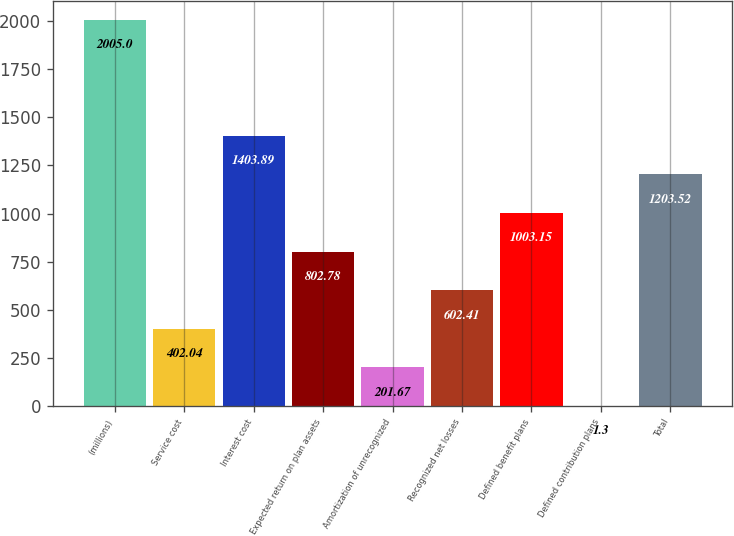Convert chart. <chart><loc_0><loc_0><loc_500><loc_500><bar_chart><fcel>(millions)<fcel>Service cost<fcel>Interest cost<fcel>Expected return on plan assets<fcel>Amortization of unrecognized<fcel>Recognized net losses<fcel>Defined benefit plans<fcel>Defined contribution plans<fcel>Total<nl><fcel>2005<fcel>402.04<fcel>1403.89<fcel>802.78<fcel>201.67<fcel>602.41<fcel>1003.15<fcel>1.3<fcel>1203.52<nl></chart> 